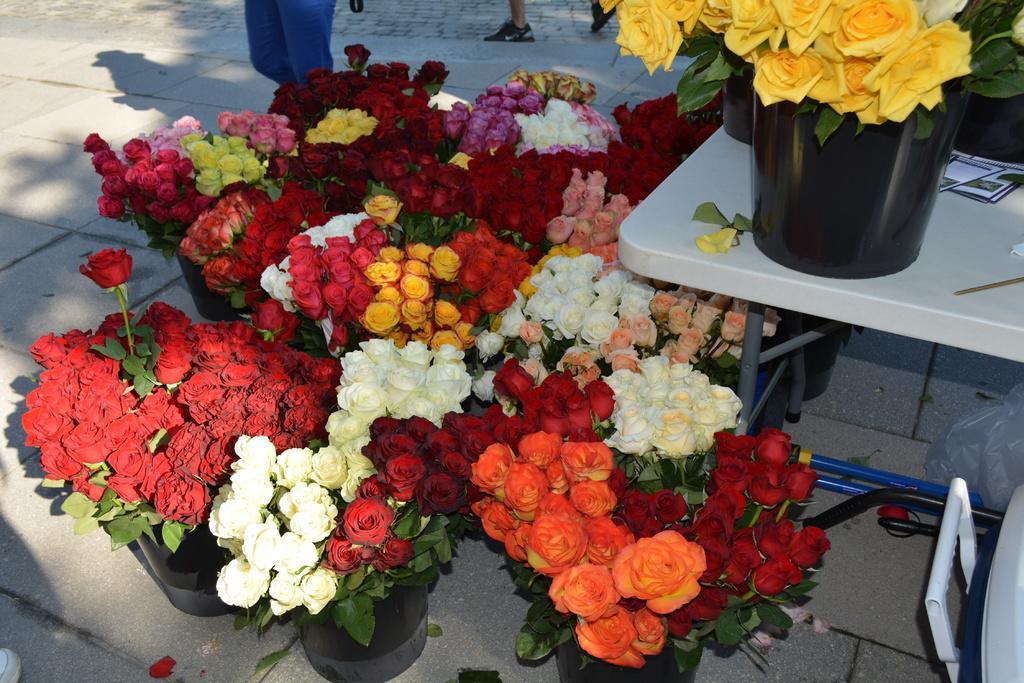Could you give a brief overview of what you see in this image? As we can see in the image there are different colors of flowers, pots and a table. In the background there is a man legs. 